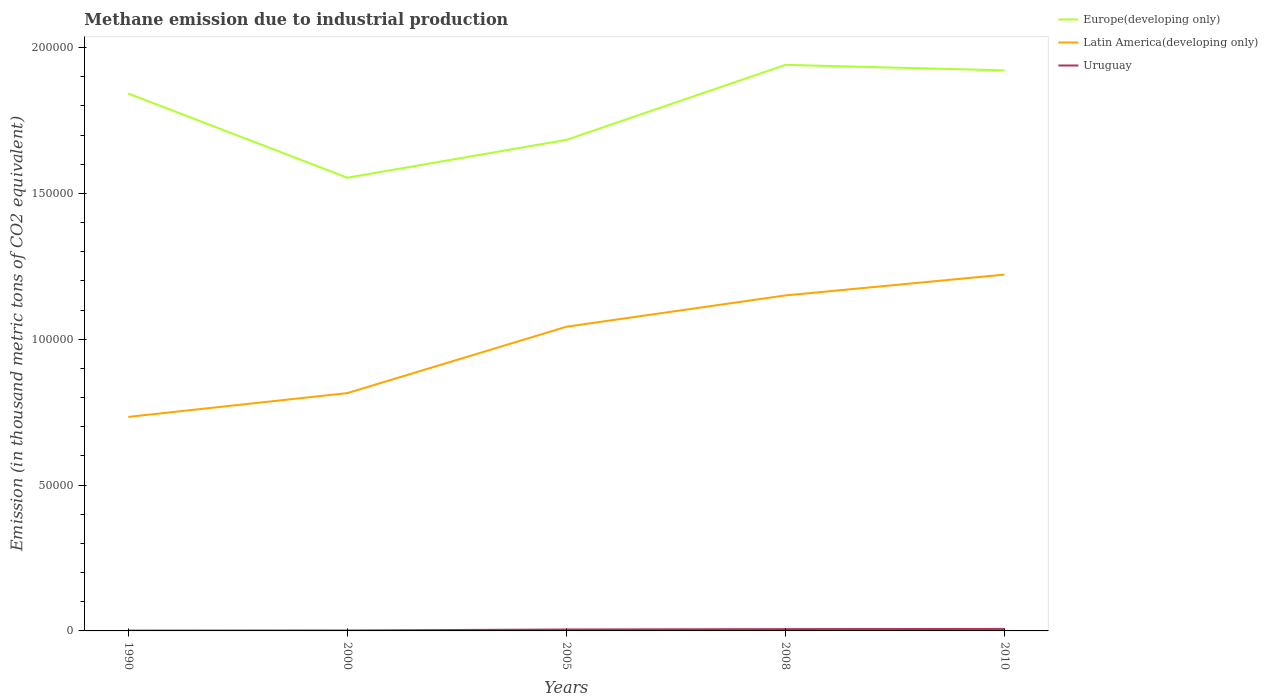Across all years, what is the maximum amount of methane emitted in Uruguay?
Keep it short and to the point. 110.3. What is the total amount of methane emitted in Latin America(developing only) in the graph?
Your response must be concise. -1.07e+04. What is the difference between the highest and the second highest amount of methane emitted in Europe(developing only)?
Offer a very short reply. 3.87e+04. What is the difference between the highest and the lowest amount of methane emitted in Latin America(developing only)?
Keep it short and to the point. 3. Is the amount of methane emitted in Europe(developing only) strictly greater than the amount of methane emitted in Uruguay over the years?
Your answer should be compact. No. How many years are there in the graph?
Provide a short and direct response. 5. What is the difference between two consecutive major ticks on the Y-axis?
Offer a terse response. 5.00e+04. Are the values on the major ticks of Y-axis written in scientific E-notation?
Your answer should be very brief. No. Does the graph contain any zero values?
Your answer should be compact. No. Where does the legend appear in the graph?
Your answer should be very brief. Top right. How many legend labels are there?
Give a very brief answer. 3. How are the legend labels stacked?
Your response must be concise. Vertical. What is the title of the graph?
Your response must be concise. Methane emission due to industrial production. Does "Mauritania" appear as one of the legend labels in the graph?
Offer a very short reply. No. What is the label or title of the X-axis?
Provide a short and direct response. Years. What is the label or title of the Y-axis?
Offer a terse response. Emission (in thousand metric tons of CO2 equivalent). What is the Emission (in thousand metric tons of CO2 equivalent) in Europe(developing only) in 1990?
Keep it short and to the point. 1.84e+05. What is the Emission (in thousand metric tons of CO2 equivalent) of Latin America(developing only) in 1990?
Provide a succinct answer. 7.34e+04. What is the Emission (in thousand metric tons of CO2 equivalent) of Uruguay in 1990?
Your answer should be very brief. 110.3. What is the Emission (in thousand metric tons of CO2 equivalent) of Europe(developing only) in 2000?
Ensure brevity in your answer.  1.55e+05. What is the Emission (in thousand metric tons of CO2 equivalent) of Latin America(developing only) in 2000?
Ensure brevity in your answer.  8.15e+04. What is the Emission (in thousand metric tons of CO2 equivalent) in Uruguay in 2000?
Provide a succinct answer. 154.4. What is the Emission (in thousand metric tons of CO2 equivalent) in Europe(developing only) in 2005?
Provide a succinct answer. 1.68e+05. What is the Emission (in thousand metric tons of CO2 equivalent) of Latin America(developing only) in 2005?
Give a very brief answer. 1.04e+05. What is the Emission (in thousand metric tons of CO2 equivalent) of Uruguay in 2005?
Your answer should be very brief. 485.4. What is the Emission (in thousand metric tons of CO2 equivalent) in Europe(developing only) in 2008?
Offer a very short reply. 1.94e+05. What is the Emission (in thousand metric tons of CO2 equivalent) in Latin America(developing only) in 2008?
Make the answer very short. 1.15e+05. What is the Emission (in thousand metric tons of CO2 equivalent) in Uruguay in 2008?
Your answer should be very brief. 622.9. What is the Emission (in thousand metric tons of CO2 equivalent) of Europe(developing only) in 2010?
Keep it short and to the point. 1.92e+05. What is the Emission (in thousand metric tons of CO2 equivalent) in Latin America(developing only) in 2010?
Your response must be concise. 1.22e+05. What is the Emission (in thousand metric tons of CO2 equivalent) of Uruguay in 2010?
Provide a short and direct response. 682.5. Across all years, what is the maximum Emission (in thousand metric tons of CO2 equivalent) in Europe(developing only)?
Give a very brief answer. 1.94e+05. Across all years, what is the maximum Emission (in thousand metric tons of CO2 equivalent) in Latin America(developing only)?
Ensure brevity in your answer.  1.22e+05. Across all years, what is the maximum Emission (in thousand metric tons of CO2 equivalent) of Uruguay?
Your answer should be compact. 682.5. Across all years, what is the minimum Emission (in thousand metric tons of CO2 equivalent) in Europe(developing only)?
Your answer should be compact. 1.55e+05. Across all years, what is the minimum Emission (in thousand metric tons of CO2 equivalent) of Latin America(developing only)?
Give a very brief answer. 7.34e+04. Across all years, what is the minimum Emission (in thousand metric tons of CO2 equivalent) in Uruguay?
Offer a terse response. 110.3. What is the total Emission (in thousand metric tons of CO2 equivalent) of Europe(developing only) in the graph?
Your answer should be very brief. 8.94e+05. What is the total Emission (in thousand metric tons of CO2 equivalent) in Latin America(developing only) in the graph?
Offer a terse response. 4.96e+05. What is the total Emission (in thousand metric tons of CO2 equivalent) in Uruguay in the graph?
Offer a terse response. 2055.5. What is the difference between the Emission (in thousand metric tons of CO2 equivalent) in Europe(developing only) in 1990 and that in 2000?
Ensure brevity in your answer.  2.88e+04. What is the difference between the Emission (in thousand metric tons of CO2 equivalent) in Latin America(developing only) in 1990 and that in 2000?
Make the answer very short. -8151.9. What is the difference between the Emission (in thousand metric tons of CO2 equivalent) of Uruguay in 1990 and that in 2000?
Your answer should be compact. -44.1. What is the difference between the Emission (in thousand metric tons of CO2 equivalent) of Europe(developing only) in 1990 and that in 2005?
Offer a terse response. 1.59e+04. What is the difference between the Emission (in thousand metric tons of CO2 equivalent) in Latin America(developing only) in 1990 and that in 2005?
Give a very brief answer. -3.09e+04. What is the difference between the Emission (in thousand metric tons of CO2 equivalent) of Uruguay in 1990 and that in 2005?
Offer a terse response. -375.1. What is the difference between the Emission (in thousand metric tons of CO2 equivalent) of Europe(developing only) in 1990 and that in 2008?
Provide a succinct answer. -9838.5. What is the difference between the Emission (in thousand metric tons of CO2 equivalent) of Latin America(developing only) in 1990 and that in 2008?
Your response must be concise. -4.16e+04. What is the difference between the Emission (in thousand metric tons of CO2 equivalent) in Uruguay in 1990 and that in 2008?
Keep it short and to the point. -512.6. What is the difference between the Emission (in thousand metric tons of CO2 equivalent) of Europe(developing only) in 1990 and that in 2010?
Provide a short and direct response. -7940.9. What is the difference between the Emission (in thousand metric tons of CO2 equivalent) in Latin America(developing only) in 1990 and that in 2010?
Your answer should be compact. -4.88e+04. What is the difference between the Emission (in thousand metric tons of CO2 equivalent) of Uruguay in 1990 and that in 2010?
Provide a succinct answer. -572.2. What is the difference between the Emission (in thousand metric tons of CO2 equivalent) in Europe(developing only) in 2000 and that in 2005?
Your answer should be compact. -1.30e+04. What is the difference between the Emission (in thousand metric tons of CO2 equivalent) of Latin America(developing only) in 2000 and that in 2005?
Give a very brief answer. -2.28e+04. What is the difference between the Emission (in thousand metric tons of CO2 equivalent) in Uruguay in 2000 and that in 2005?
Provide a succinct answer. -331. What is the difference between the Emission (in thousand metric tons of CO2 equivalent) of Europe(developing only) in 2000 and that in 2008?
Make the answer very short. -3.87e+04. What is the difference between the Emission (in thousand metric tons of CO2 equivalent) of Latin America(developing only) in 2000 and that in 2008?
Keep it short and to the point. -3.35e+04. What is the difference between the Emission (in thousand metric tons of CO2 equivalent) in Uruguay in 2000 and that in 2008?
Make the answer very short. -468.5. What is the difference between the Emission (in thousand metric tons of CO2 equivalent) in Europe(developing only) in 2000 and that in 2010?
Offer a terse response. -3.68e+04. What is the difference between the Emission (in thousand metric tons of CO2 equivalent) of Latin America(developing only) in 2000 and that in 2010?
Give a very brief answer. -4.06e+04. What is the difference between the Emission (in thousand metric tons of CO2 equivalent) of Uruguay in 2000 and that in 2010?
Keep it short and to the point. -528.1. What is the difference between the Emission (in thousand metric tons of CO2 equivalent) in Europe(developing only) in 2005 and that in 2008?
Provide a short and direct response. -2.57e+04. What is the difference between the Emission (in thousand metric tons of CO2 equivalent) of Latin America(developing only) in 2005 and that in 2008?
Provide a succinct answer. -1.07e+04. What is the difference between the Emission (in thousand metric tons of CO2 equivalent) of Uruguay in 2005 and that in 2008?
Give a very brief answer. -137.5. What is the difference between the Emission (in thousand metric tons of CO2 equivalent) in Europe(developing only) in 2005 and that in 2010?
Ensure brevity in your answer.  -2.38e+04. What is the difference between the Emission (in thousand metric tons of CO2 equivalent) in Latin America(developing only) in 2005 and that in 2010?
Your answer should be very brief. -1.79e+04. What is the difference between the Emission (in thousand metric tons of CO2 equivalent) of Uruguay in 2005 and that in 2010?
Provide a succinct answer. -197.1. What is the difference between the Emission (in thousand metric tons of CO2 equivalent) in Europe(developing only) in 2008 and that in 2010?
Keep it short and to the point. 1897.6. What is the difference between the Emission (in thousand metric tons of CO2 equivalent) of Latin America(developing only) in 2008 and that in 2010?
Your response must be concise. -7129.8. What is the difference between the Emission (in thousand metric tons of CO2 equivalent) of Uruguay in 2008 and that in 2010?
Your response must be concise. -59.6. What is the difference between the Emission (in thousand metric tons of CO2 equivalent) of Europe(developing only) in 1990 and the Emission (in thousand metric tons of CO2 equivalent) of Latin America(developing only) in 2000?
Give a very brief answer. 1.03e+05. What is the difference between the Emission (in thousand metric tons of CO2 equivalent) in Europe(developing only) in 1990 and the Emission (in thousand metric tons of CO2 equivalent) in Uruguay in 2000?
Your response must be concise. 1.84e+05. What is the difference between the Emission (in thousand metric tons of CO2 equivalent) of Latin America(developing only) in 1990 and the Emission (in thousand metric tons of CO2 equivalent) of Uruguay in 2000?
Make the answer very short. 7.32e+04. What is the difference between the Emission (in thousand metric tons of CO2 equivalent) of Europe(developing only) in 1990 and the Emission (in thousand metric tons of CO2 equivalent) of Latin America(developing only) in 2005?
Offer a terse response. 7.99e+04. What is the difference between the Emission (in thousand metric tons of CO2 equivalent) of Europe(developing only) in 1990 and the Emission (in thousand metric tons of CO2 equivalent) of Uruguay in 2005?
Provide a succinct answer. 1.84e+05. What is the difference between the Emission (in thousand metric tons of CO2 equivalent) in Latin America(developing only) in 1990 and the Emission (in thousand metric tons of CO2 equivalent) in Uruguay in 2005?
Ensure brevity in your answer.  7.29e+04. What is the difference between the Emission (in thousand metric tons of CO2 equivalent) of Europe(developing only) in 1990 and the Emission (in thousand metric tons of CO2 equivalent) of Latin America(developing only) in 2008?
Your answer should be very brief. 6.92e+04. What is the difference between the Emission (in thousand metric tons of CO2 equivalent) of Europe(developing only) in 1990 and the Emission (in thousand metric tons of CO2 equivalent) of Uruguay in 2008?
Keep it short and to the point. 1.84e+05. What is the difference between the Emission (in thousand metric tons of CO2 equivalent) of Latin America(developing only) in 1990 and the Emission (in thousand metric tons of CO2 equivalent) of Uruguay in 2008?
Provide a short and direct response. 7.28e+04. What is the difference between the Emission (in thousand metric tons of CO2 equivalent) in Europe(developing only) in 1990 and the Emission (in thousand metric tons of CO2 equivalent) in Latin America(developing only) in 2010?
Give a very brief answer. 6.21e+04. What is the difference between the Emission (in thousand metric tons of CO2 equivalent) in Europe(developing only) in 1990 and the Emission (in thousand metric tons of CO2 equivalent) in Uruguay in 2010?
Keep it short and to the point. 1.84e+05. What is the difference between the Emission (in thousand metric tons of CO2 equivalent) of Latin America(developing only) in 1990 and the Emission (in thousand metric tons of CO2 equivalent) of Uruguay in 2010?
Your answer should be very brief. 7.27e+04. What is the difference between the Emission (in thousand metric tons of CO2 equivalent) in Europe(developing only) in 2000 and the Emission (in thousand metric tons of CO2 equivalent) in Latin America(developing only) in 2005?
Make the answer very short. 5.11e+04. What is the difference between the Emission (in thousand metric tons of CO2 equivalent) of Europe(developing only) in 2000 and the Emission (in thousand metric tons of CO2 equivalent) of Uruguay in 2005?
Give a very brief answer. 1.55e+05. What is the difference between the Emission (in thousand metric tons of CO2 equivalent) of Latin America(developing only) in 2000 and the Emission (in thousand metric tons of CO2 equivalent) of Uruguay in 2005?
Your response must be concise. 8.10e+04. What is the difference between the Emission (in thousand metric tons of CO2 equivalent) of Europe(developing only) in 2000 and the Emission (in thousand metric tons of CO2 equivalent) of Latin America(developing only) in 2008?
Offer a very short reply. 4.04e+04. What is the difference between the Emission (in thousand metric tons of CO2 equivalent) of Europe(developing only) in 2000 and the Emission (in thousand metric tons of CO2 equivalent) of Uruguay in 2008?
Provide a short and direct response. 1.55e+05. What is the difference between the Emission (in thousand metric tons of CO2 equivalent) of Latin America(developing only) in 2000 and the Emission (in thousand metric tons of CO2 equivalent) of Uruguay in 2008?
Your response must be concise. 8.09e+04. What is the difference between the Emission (in thousand metric tons of CO2 equivalent) in Europe(developing only) in 2000 and the Emission (in thousand metric tons of CO2 equivalent) in Latin America(developing only) in 2010?
Offer a very short reply. 3.32e+04. What is the difference between the Emission (in thousand metric tons of CO2 equivalent) of Europe(developing only) in 2000 and the Emission (in thousand metric tons of CO2 equivalent) of Uruguay in 2010?
Make the answer very short. 1.55e+05. What is the difference between the Emission (in thousand metric tons of CO2 equivalent) of Latin America(developing only) in 2000 and the Emission (in thousand metric tons of CO2 equivalent) of Uruguay in 2010?
Your answer should be very brief. 8.09e+04. What is the difference between the Emission (in thousand metric tons of CO2 equivalent) of Europe(developing only) in 2005 and the Emission (in thousand metric tons of CO2 equivalent) of Latin America(developing only) in 2008?
Offer a very short reply. 5.33e+04. What is the difference between the Emission (in thousand metric tons of CO2 equivalent) in Europe(developing only) in 2005 and the Emission (in thousand metric tons of CO2 equivalent) in Uruguay in 2008?
Offer a terse response. 1.68e+05. What is the difference between the Emission (in thousand metric tons of CO2 equivalent) of Latin America(developing only) in 2005 and the Emission (in thousand metric tons of CO2 equivalent) of Uruguay in 2008?
Offer a terse response. 1.04e+05. What is the difference between the Emission (in thousand metric tons of CO2 equivalent) of Europe(developing only) in 2005 and the Emission (in thousand metric tons of CO2 equivalent) of Latin America(developing only) in 2010?
Give a very brief answer. 4.62e+04. What is the difference between the Emission (in thousand metric tons of CO2 equivalent) of Europe(developing only) in 2005 and the Emission (in thousand metric tons of CO2 equivalent) of Uruguay in 2010?
Ensure brevity in your answer.  1.68e+05. What is the difference between the Emission (in thousand metric tons of CO2 equivalent) of Latin America(developing only) in 2005 and the Emission (in thousand metric tons of CO2 equivalent) of Uruguay in 2010?
Offer a very short reply. 1.04e+05. What is the difference between the Emission (in thousand metric tons of CO2 equivalent) of Europe(developing only) in 2008 and the Emission (in thousand metric tons of CO2 equivalent) of Latin America(developing only) in 2010?
Offer a very short reply. 7.19e+04. What is the difference between the Emission (in thousand metric tons of CO2 equivalent) of Europe(developing only) in 2008 and the Emission (in thousand metric tons of CO2 equivalent) of Uruguay in 2010?
Your answer should be compact. 1.93e+05. What is the difference between the Emission (in thousand metric tons of CO2 equivalent) of Latin America(developing only) in 2008 and the Emission (in thousand metric tons of CO2 equivalent) of Uruguay in 2010?
Your response must be concise. 1.14e+05. What is the average Emission (in thousand metric tons of CO2 equivalent) of Europe(developing only) per year?
Your response must be concise. 1.79e+05. What is the average Emission (in thousand metric tons of CO2 equivalent) in Latin America(developing only) per year?
Your answer should be compact. 9.93e+04. What is the average Emission (in thousand metric tons of CO2 equivalent) of Uruguay per year?
Offer a terse response. 411.1. In the year 1990, what is the difference between the Emission (in thousand metric tons of CO2 equivalent) in Europe(developing only) and Emission (in thousand metric tons of CO2 equivalent) in Latin America(developing only)?
Offer a very short reply. 1.11e+05. In the year 1990, what is the difference between the Emission (in thousand metric tons of CO2 equivalent) in Europe(developing only) and Emission (in thousand metric tons of CO2 equivalent) in Uruguay?
Provide a short and direct response. 1.84e+05. In the year 1990, what is the difference between the Emission (in thousand metric tons of CO2 equivalent) of Latin America(developing only) and Emission (in thousand metric tons of CO2 equivalent) of Uruguay?
Give a very brief answer. 7.33e+04. In the year 2000, what is the difference between the Emission (in thousand metric tons of CO2 equivalent) in Europe(developing only) and Emission (in thousand metric tons of CO2 equivalent) in Latin America(developing only)?
Keep it short and to the point. 7.39e+04. In the year 2000, what is the difference between the Emission (in thousand metric tons of CO2 equivalent) of Europe(developing only) and Emission (in thousand metric tons of CO2 equivalent) of Uruguay?
Offer a terse response. 1.55e+05. In the year 2000, what is the difference between the Emission (in thousand metric tons of CO2 equivalent) in Latin America(developing only) and Emission (in thousand metric tons of CO2 equivalent) in Uruguay?
Provide a succinct answer. 8.14e+04. In the year 2005, what is the difference between the Emission (in thousand metric tons of CO2 equivalent) of Europe(developing only) and Emission (in thousand metric tons of CO2 equivalent) of Latin America(developing only)?
Give a very brief answer. 6.41e+04. In the year 2005, what is the difference between the Emission (in thousand metric tons of CO2 equivalent) in Europe(developing only) and Emission (in thousand metric tons of CO2 equivalent) in Uruguay?
Make the answer very short. 1.68e+05. In the year 2005, what is the difference between the Emission (in thousand metric tons of CO2 equivalent) in Latin America(developing only) and Emission (in thousand metric tons of CO2 equivalent) in Uruguay?
Make the answer very short. 1.04e+05. In the year 2008, what is the difference between the Emission (in thousand metric tons of CO2 equivalent) in Europe(developing only) and Emission (in thousand metric tons of CO2 equivalent) in Latin America(developing only)?
Provide a succinct answer. 7.90e+04. In the year 2008, what is the difference between the Emission (in thousand metric tons of CO2 equivalent) in Europe(developing only) and Emission (in thousand metric tons of CO2 equivalent) in Uruguay?
Your answer should be very brief. 1.93e+05. In the year 2008, what is the difference between the Emission (in thousand metric tons of CO2 equivalent) in Latin America(developing only) and Emission (in thousand metric tons of CO2 equivalent) in Uruguay?
Ensure brevity in your answer.  1.14e+05. In the year 2010, what is the difference between the Emission (in thousand metric tons of CO2 equivalent) of Europe(developing only) and Emission (in thousand metric tons of CO2 equivalent) of Latin America(developing only)?
Provide a short and direct response. 7.00e+04. In the year 2010, what is the difference between the Emission (in thousand metric tons of CO2 equivalent) of Europe(developing only) and Emission (in thousand metric tons of CO2 equivalent) of Uruguay?
Your response must be concise. 1.91e+05. In the year 2010, what is the difference between the Emission (in thousand metric tons of CO2 equivalent) in Latin America(developing only) and Emission (in thousand metric tons of CO2 equivalent) in Uruguay?
Your answer should be compact. 1.21e+05. What is the ratio of the Emission (in thousand metric tons of CO2 equivalent) of Europe(developing only) in 1990 to that in 2000?
Provide a succinct answer. 1.19. What is the ratio of the Emission (in thousand metric tons of CO2 equivalent) in Latin America(developing only) in 1990 to that in 2000?
Your answer should be compact. 0.9. What is the ratio of the Emission (in thousand metric tons of CO2 equivalent) of Uruguay in 1990 to that in 2000?
Ensure brevity in your answer.  0.71. What is the ratio of the Emission (in thousand metric tons of CO2 equivalent) of Europe(developing only) in 1990 to that in 2005?
Ensure brevity in your answer.  1.09. What is the ratio of the Emission (in thousand metric tons of CO2 equivalent) in Latin America(developing only) in 1990 to that in 2005?
Your response must be concise. 0.7. What is the ratio of the Emission (in thousand metric tons of CO2 equivalent) in Uruguay in 1990 to that in 2005?
Provide a succinct answer. 0.23. What is the ratio of the Emission (in thousand metric tons of CO2 equivalent) in Europe(developing only) in 1990 to that in 2008?
Ensure brevity in your answer.  0.95. What is the ratio of the Emission (in thousand metric tons of CO2 equivalent) of Latin America(developing only) in 1990 to that in 2008?
Offer a terse response. 0.64. What is the ratio of the Emission (in thousand metric tons of CO2 equivalent) of Uruguay in 1990 to that in 2008?
Your response must be concise. 0.18. What is the ratio of the Emission (in thousand metric tons of CO2 equivalent) of Europe(developing only) in 1990 to that in 2010?
Give a very brief answer. 0.96. What is the ratio of the Emission (in thousand metric tons of CO2 equivalent) of Latin America(developing only) in 1990 to that in 2010?
Your answer should be compact. 0.6. What is the ratio of the Emission (in thousand metric tons of CO2 equivalent) in Uruguay in 1990 to that in 2010?
Offer a terse response. 0.16. What is the ratio of the Emission (in thousand metric tons of CO2 equivalent) of Europe(developing only) in 2000 to that in 2005?
Provide a short and direct response. 0.92. What is the ratio of the Emission (in thousand metric tons of CO2 equivalent) in Latin America(developing only) in 2000 to that in 2005?
Ensure brevity in your answer.  0.78. What is the ratio of the Emission (in thousand metric tons of CO2 equivalent) of Uruguay in 2000 to that in 2005?
Offer a terse response. 0.32. What is the ratio of the Emission (in thousand metric tons of CO2 equivalent) of Europe(developing only) in 2000 to that in 2008?
Keep it short and to the point. 0.8. What is the ratio of the Emission (in thousand metric tons of CO2 equivalent) in Latin America(developing only) in 2000 to that in 2008?
Your response must be concise. 0.71. What is the ratio of the Emission (in thousand metric tons of CO2 equivalent) of Uruguay in 2000 to that in 2008?
Keep it short and to the point. 0.25. What is the ratio of the Emission (in thousand metric tons of CO2 equivalent) in Europe(developing only) in 2000 to that in 2010?
Provide a short and direct response. 0.81. What is the ratio of the Emission (in thousand metric tons of CO2 equivalent) in Latin America(developing only) in 2000 to that in 2010?
Make the answer very short. 0.67. What is the ratio of the Emission (in thousand metric tons of CO2 equivalent) in Uruguay in 2000 to that in 2010?
Offer a very short reply. 0.23. What is the ratio of the Emission (in thousand metric tons of CO2 equivalent) of Europe(developing only) in 2005 to that in 2008?
Offer a terse response. 0.87. What is the ratio of the Emission (in thousand metric tons of CO2 equivalent) in Latin America(developing only) in 2005 to that in 2008?
Offer a terse response. 0.91. What is the ratio of the Emission (in thousand metric tons of CO2 equivalent) in Uruguay in 2005 to that in 2008?
Ensure brevity in your answer.  0.78. What is the ratio of the Emission (in thousand metric tons of CO2 equivalent) in Europe(developing only) in 2005 to that in 2010?
Your response must be concise. 0.88. What is the ratio of the Emission (in thousand metric tons of CO2 equivalent) of Latin America(developing only) in 2005 to that in 2010?
Offer a terse response. 0.85. What is the ratio of the Emission (in thousand metric tons of CO2 equivalent) of Uruguay in 2005 to that in 2010?
Provide a short and direct response. 0.71. What is the ratio of the Emission (in thousand metric tons of CO2 equivalent) of Europe(developing only) in 2008 to that in 2010?
Make the answer very short. 1.01. What is the ratio of the Emission (in thousand metric tons of CO2 equivalent) of Latin America(developing only) in 2008 to that in 2010?
Ensure brevity in your answer.  0.94. What is the ratio of the Emission (in thousand metric tons of CO2 equivalent) of Uruguay in 2008 to that in 2010?
Make the answer very short. 0.91. What is the difference between the highest and the second highest Emission (in thousand metric tons of CO2 equivalent) of Europe(developing only)?
Provide a short and direct response. 1897.6. What is the difference between the highest and the second highest Emission (in thousand metric tons of CO2 equivalent) in Latin America(developing only)?
Provide a succinct answer. 7129.8. What is the difference between the highest and the second highest Emission (in thousand metric tons of CO2 equivalent) in Uruguay?
Provide a succinct answer. 59.6. What is the difference between the highest and the lowest Emission (in thousand metric tons of CO2 equivalent) of Europe(developing only)?
Provide a short and direct response. 3.87e+04. What is the difference between the highest and the lowest Emission (in thousand metric tons of CO2 equivalent) in Latin America(developing only)?
Provide a succinct answer. 4.88e+04. What is the difference between the highest and the lowest Emission (in thousand metric tons of CO2 equivalent) of Uruguay?
Offer a very short reply. 572.2. 